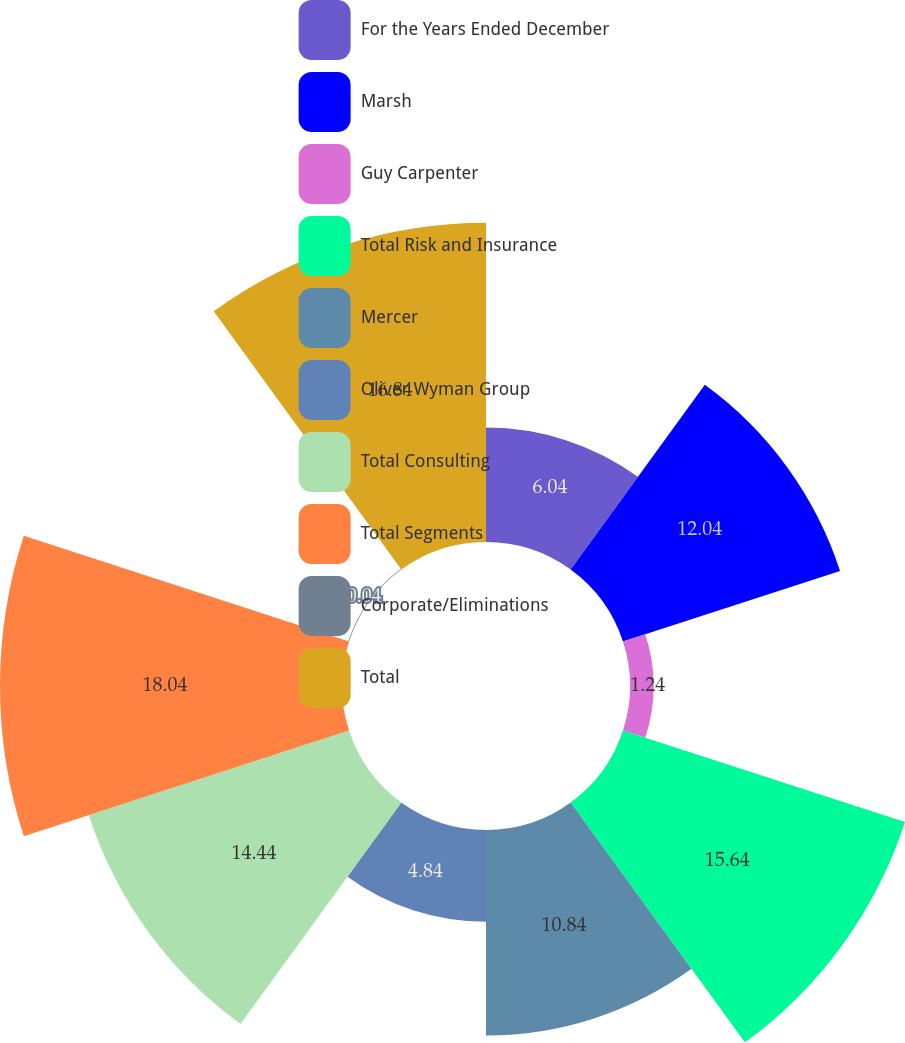Convert chart. <chart><loc_0><loc_0><loc_500><loc_500><pie_chart><fcel>For the Years Ended December<fcel>Marsh<fcel>Guy Carpenter<fcel>Total Risk and Insurance<fcel>Mercer<fcel>Oliver Wyman Group<fcel>Total Consulting<fcel>Total Segments<fcel>Corporate/Eliminations<fcel>Total<nl><fcel>6.04%<fcel>12.04%<fcel>1.24%<fcel>15.64%<fcel>10.84%<fcel>4.84%<fcel>14.44%<fcel>18.04%<fcel>0.04%<fcel>16.84%<nl></chart> 